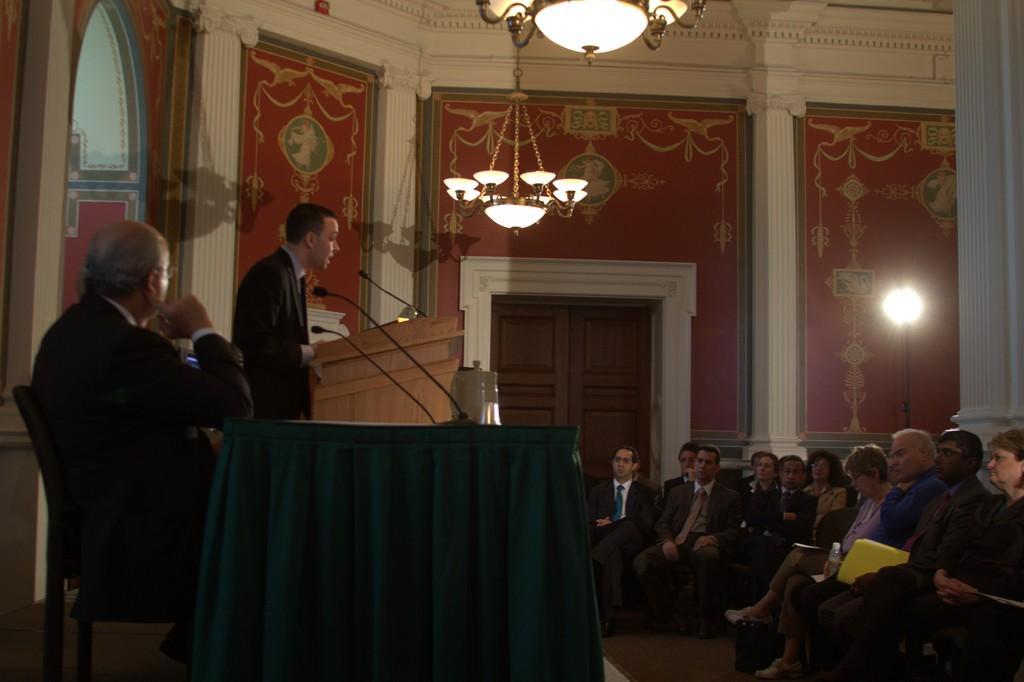Can you describe this image briefly? In the foreground of this image, on the left, there is a man sitting on the chair in front of a table on which two mics and an object are placed. Behind him, there is a man standing near a podium on which there is a mic. On the right, there are persons sitting on the chairs. In the background, there is a wall, light, two chandeliers and the door. 